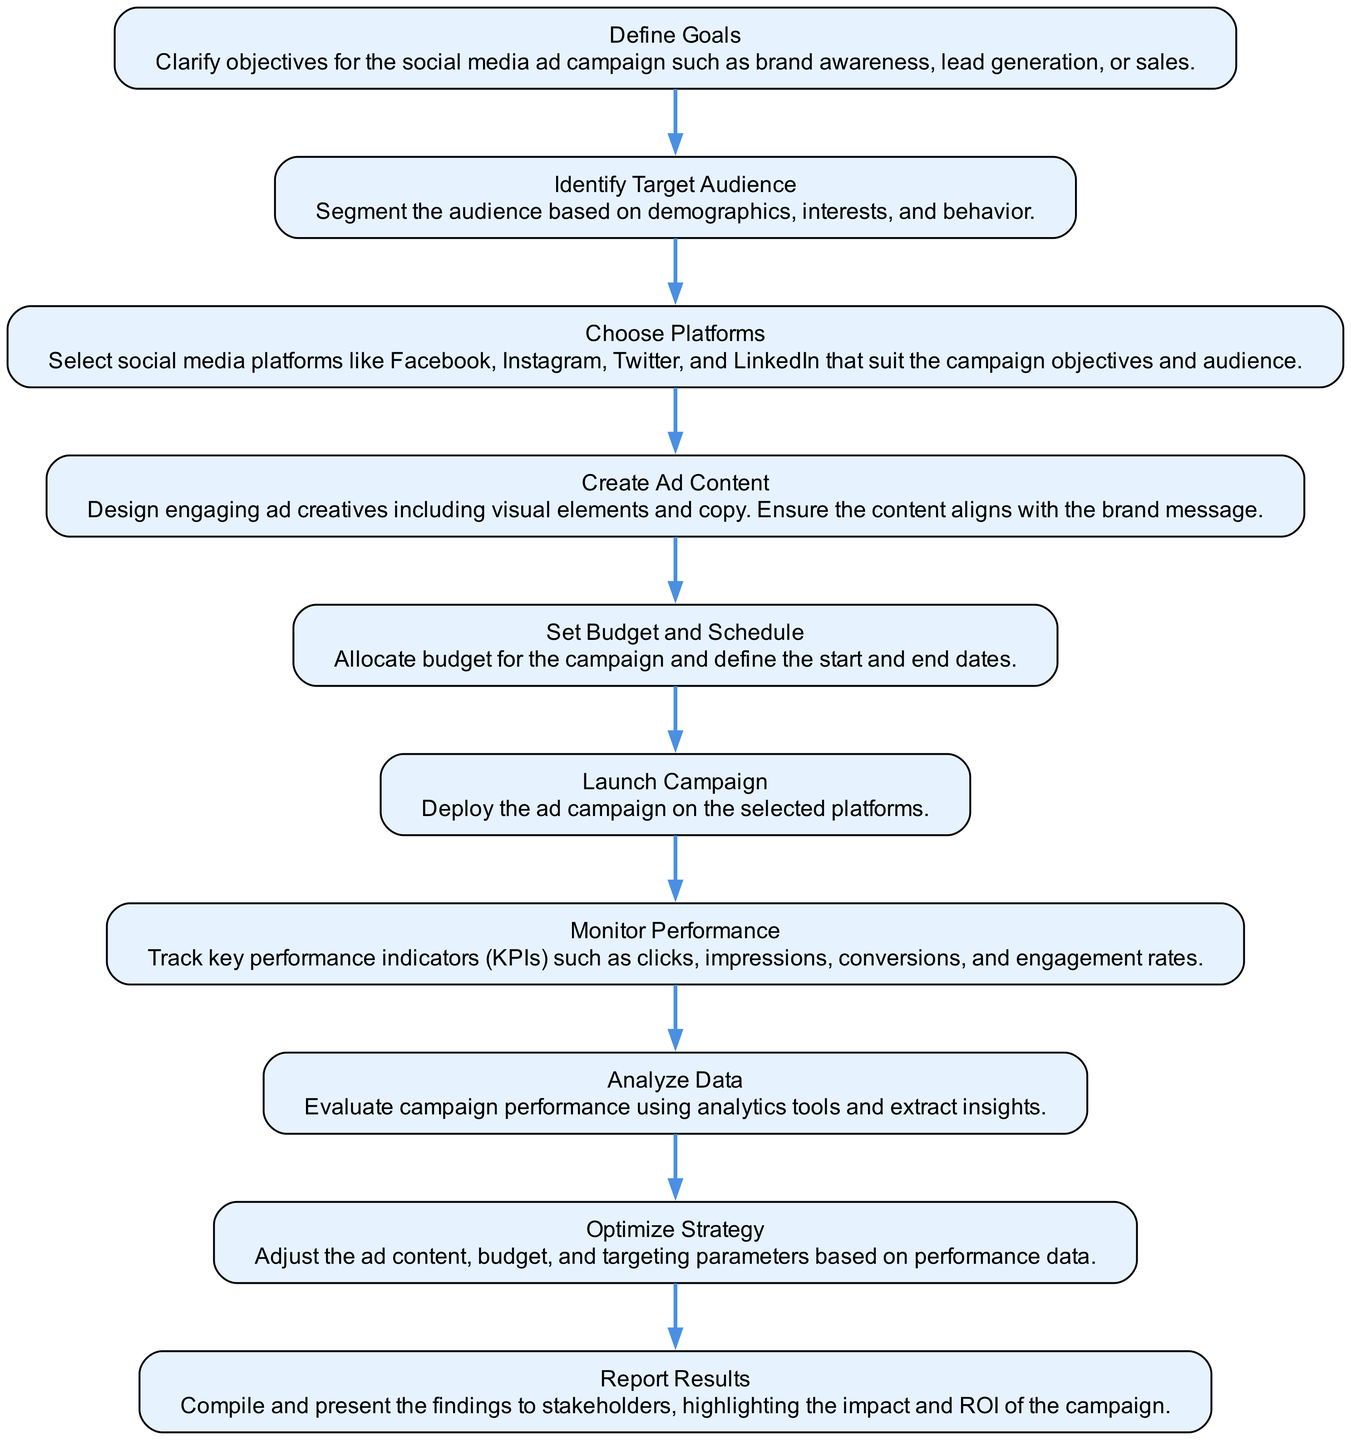What is the first step in the diagram? The first step in the diagram is defined as "Define Goals." This is indicated as the topmost node in the flow chart.
Answer: Define Goals How many nodes are in the diagram? Counting all the distinct steps from "Define Goals" to "Report Results," there are ten nodes in total. This includes all the main steps outlined in the flow chart.
Answer: 10 What does the "Launch Campaign" node depend on? The "Launch Campaign" node depends on the previous step, which is "Set Budget and Schedule." This indicates that you must set the budget and schedule before launching the campaign.
Answer: Set Budget and Schedule Which step comes directly after "Create Ad Content"? Directly after "Create Ad Content," the next step in the sequence is "Set Budget and Schedule." This illustrates the order in executing the components of the strategy.
Answer: Set Budget and Schedule In which step do you analyze data? You analyze data in the "Analyze Data" step, which follows the "Monitor Performance" node. This step focuses on evaluating the performance after monitoring the key metrics.
Answer: Analyze Data What is a key performance indicator tracked in the "Monitor Performance" node? A key performance indicator tracked includes metrics like clicks, impressions, or engagement rates. This information is highlighted within that specific node's description.
Answer: Clicks What action follows "Optimize Strategy"? The action that follows "Optimize Strategy" is "Report Results." This indicates that after optimizing, the next logical step is to compile and present the campaign's findings.
Answer: Report Results Which step involves defining the target audience? The step that involves defining the target audience is "Identify Target Audience." This node explicitly describes the process of segmenting the audience.
Answer: Identify Target Audience How does the "Choose Platforms" node relate to "Define Goals"? The "Choose Platforms" node is directly related to "Define Goals" as it comes right after it in the flow, suggesting that the selection of platforms is based on the initial goals defined in the first step.
Answer: By following and aligning with the goals 